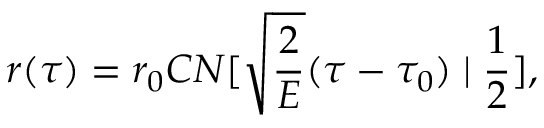<formula> <loc_0><loc_0><loc_500><loc_500>r ( \tau ) = r _ { 0 } C N [ \sqrt { \frac { 2 } { E } } ( \tau - \tau _ { 0 } ) | \frac { 1 } { 2 } ] ,</formula> 